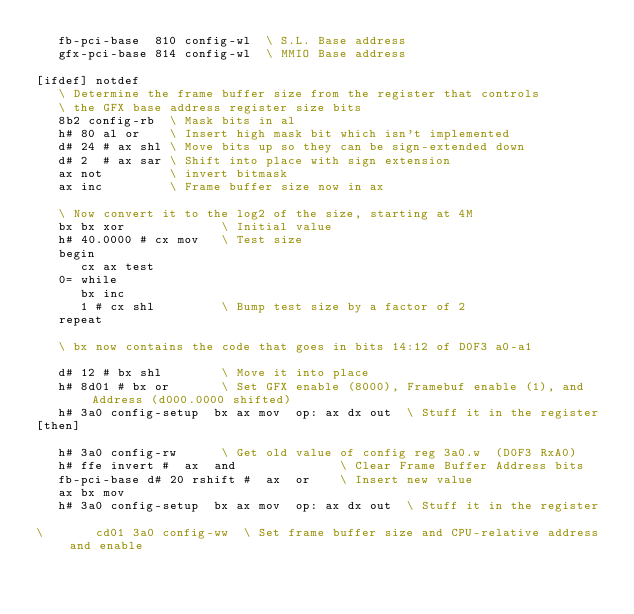Convert code to text. <code><loc_0><loc_0><loc_500><loc_500><_Forth_>   fb-pci-base  810 config-wl  \ S.L. Base address
   gfx-pci-base 814 config-wl  \ MMIO Base address

[ifdef] notdef
   \ Determine the frame buffer size from the register that controls
   \ the GFX base address register size bits
   8b2 config-rb  \ Mask bits in al
   h# 80 al or    \ Insert high mask bit which isn't implemented
   d# 24 # ax shl \ Move bits up so they can be sign-extended down
   d# 2  # ax sar \ Shift into place with sign extension
   ax not         \ invert bitmask
   ax inc         \ Frame buffer size now in ax

   \ Now convert it to the log2 of the size, starting at 4M
   bx bx xor             \ Initial value
   h# 40.0000 # cx mov   \ Test size
   begin
      cx ax test
   0= while
      bx inc
      1 # cx shl         \ Bump test size by a factor of 2
   repeat

   \ bx now contains the code that goes in bits 14:12 of D0F3 a0-a1

   d# 12 # bx shl        \ Move it into place
   h# 8d01 # bx or       \ Set GFX enable (8000), Framebuf enable (1), and Address (d000.0000 shifted)
   h# 3a0 config-setup  bx ax mov  op: ax dx out  \ Stuff it in the register
[then]

   h# 3a0 config-rw      \ Get old value of config reg 3a0.w  (D0F3 RxA0)
   h# ffe invert #  ax  and              \ Clear Frame Buffer Address bits
   fb-pci-base d# 20 rshift #  ax  or    \ Insert new value
   ax bx mov
   h# 3a0 config-setup  bx ax mov  op: ax dx out  \ Stuff it in the register   

\       cd01 3a0 config-ww  \ Set frame buffer size and CPU-relative address and enable
</code> 